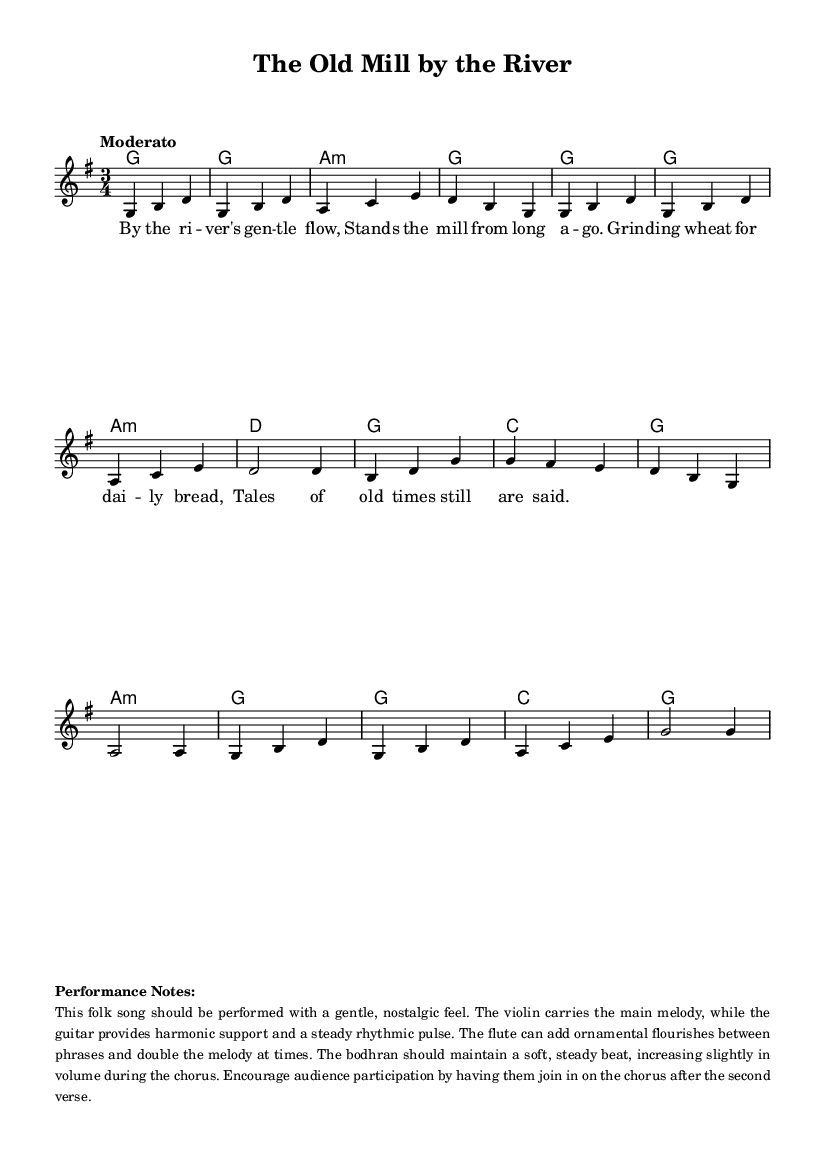What is the key signature of this music? The key signature shown in the score indicates a G major key, which contains one sharp (F#). This is determined by the key signature symbol at the beginning of the staff.
Answer: G major What is the time signature of this music? The time signature displayed at the beginning of the piece is 3/4, indicating there are three beats per measure and the quarter note gets one beat. This can be found by looking at the symbol next to the key signature.
Answer: 3/4 What is the tempo marking for this piece? The tempo marking provided in the score states "Moderato," which suggests a moderate speed of performance. This is indicated above the staff where tempo markings are usually located.
Answer: Moderato How many measures are in the first verse? The first verse consists of four measures as indicated by the grouping of notes and bar lines. Counting the musical phrases that contain lyrics confirms this.
Answer: Four measures What instruments are suggested for this performance? The performance notes in the markup indicate that the violin carries the melody, guitar provides harmony, flute adds ornamentation, and the bodhran maintains rhythm. This information reveals the recommended instrumentation.
Answer: Violin, guitar, flute, bodhran What is the primary vocal style suggested for this folk song? The score mentions encouraging audience participation during the chorus, which implies a communal, sing-along vocal style characteristic of many folk songs. This is derived from the performance notes section.
Answer: Communal, sing-along 